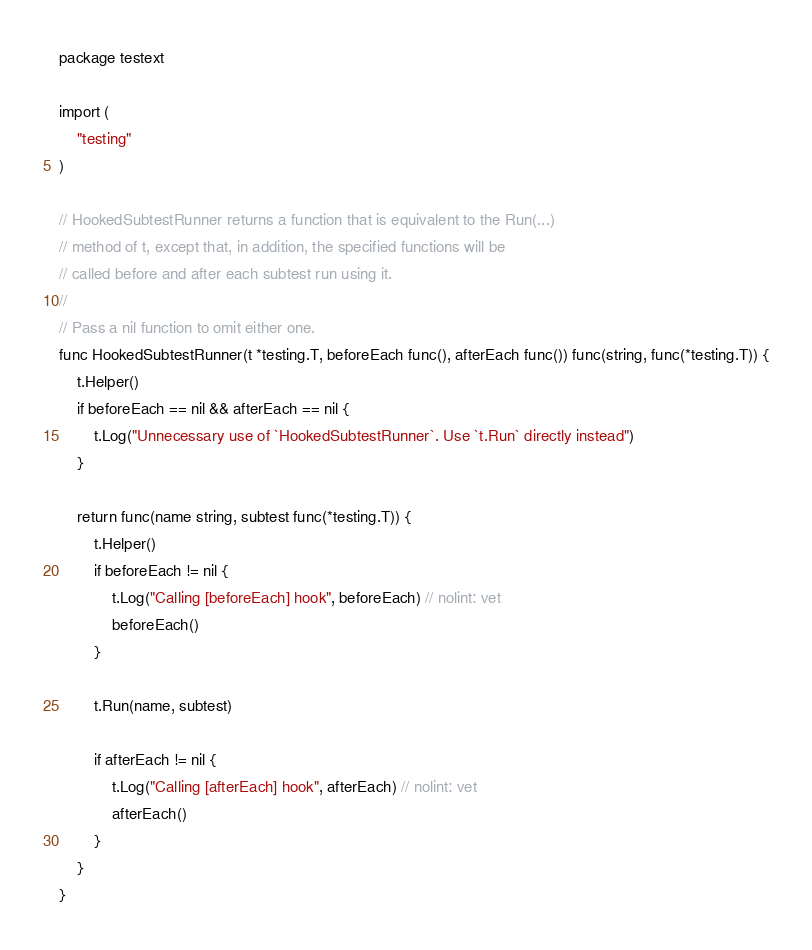Convert code to text. <code><loc_0><loc_0><loc_500><loc_500><_Go_>package testext

import (
	"testing"
)

// HookedSubtestRunner returns a function that is equivalent to the Run(...)
// method of t, except that, in addition, the specified functions will be
// called before and after each subtest run using it.
//
// Pass a nil function to omit either one.
func HookedSubtestRunner(t *testing.T, beforeEach func(), afterEach func()) func(string, func(*testing.T)) {
	t.Helper()
	if beforeEach == nil && afterEach == nil {
		t.Log("Unnecessary use of `HookedSubtestRunner`. Use `t.Run` directly instead")
	}

	return func(name string, subtest func(*testing.T)) {
		t.Helper()
		if beforeEach != nil {
			t.Log("Calling [beforeEach] hook", beforeEach) // nolint: vet
			beforeEach()
		}

		t.Run(name, subtest)

		if afterEach != nil {
			t.Log("Calling [afterEach] hook", afterEach) // nolint: vet
			afterEach()
		}
	}
}
</code> 